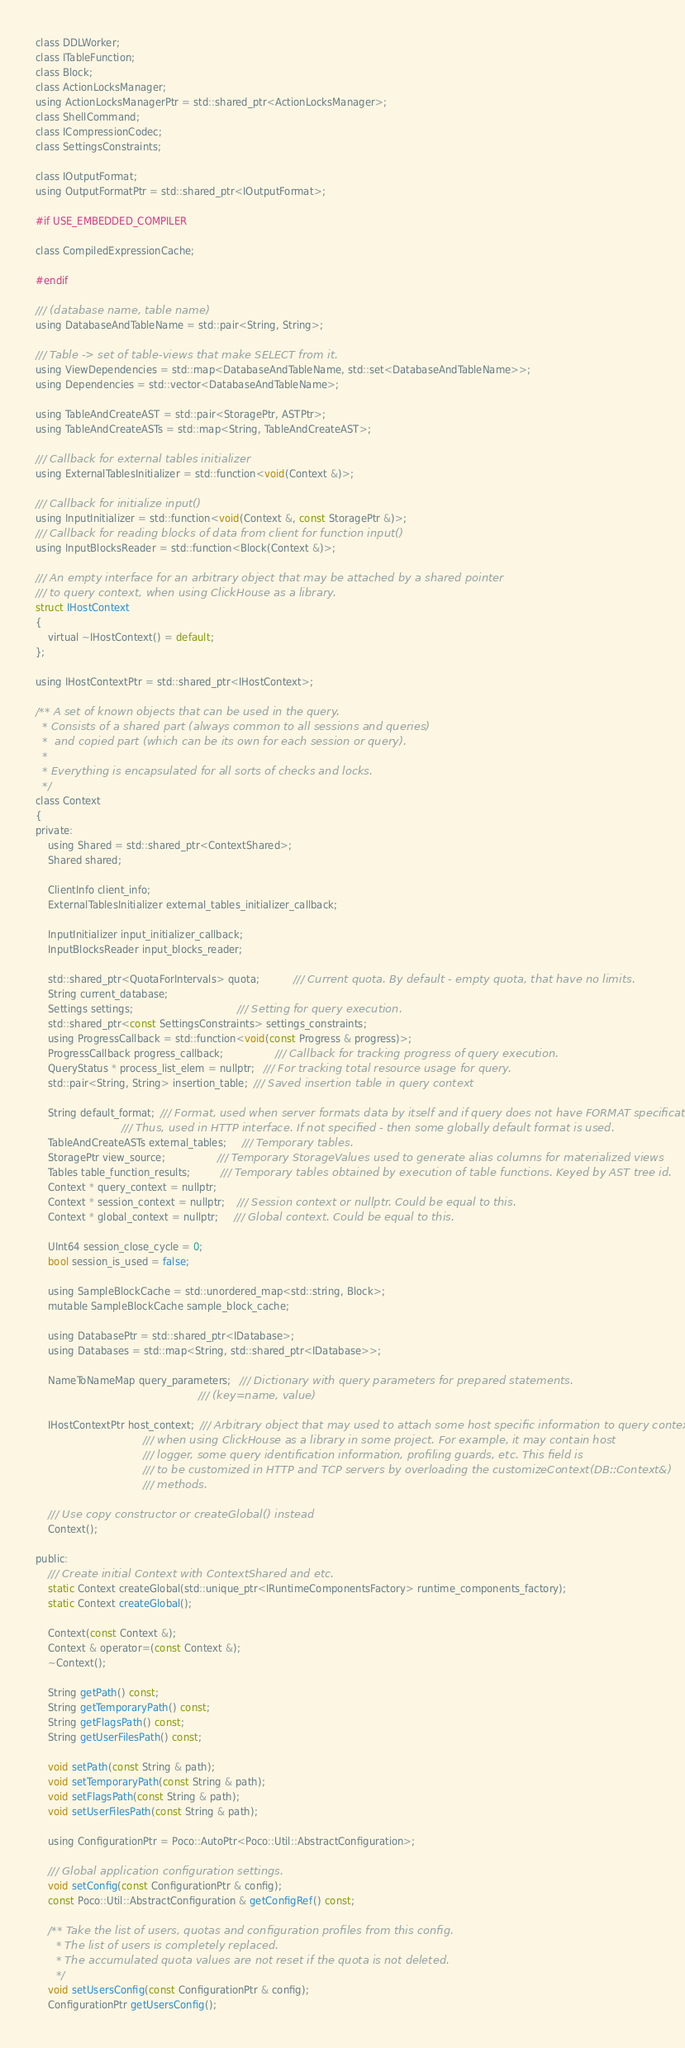Convert code to text. <code><loc_0><loc_0><loc_500><loc_500><_C_>class DDLWorker;
class ITableFunction;
class Block;
class ActionLocksManager;
using ActionLocksManagerPtr = std::shared_ptr<ActionLocksManager>;
class ShellCommand;
class ICompressionCodec;
class SettingsConstraints;

class IOutputFormat;
using OutputFormatPtr = std::shared_ptr<IOutputFormat>;

#if USE_EMBEDDED_COMPILER

class CompiledExpressionCache;

#endif

/// (database name, table name)
using DatabaseAndTableName = std::pair<String, String>;

/// Table -> set of table-views that make SELECT from it.
using ViewDependencies = std::map<DatabaseAndTableName, std::set<DatabaseAndTableName>>;
using Dependencies = std::vector<DatabaseAndTableName>;

using TableAndCreateAST = std::pair<StoragePtr, ASTPtr>;
using TableAndCreateASTs = std::map<String, TableAndCreateAST>;

/// Callback for external tables initializer
using ExternalTablesInitializer = std::function<void(Context &)>;

/// Callback for initialize input()
using InputInitializer = std::function<void(Context &, const StoragePtr &)>;
/// Callback for reading blocks of data from client for function input()
using InputBlocksReader = std::function<Block(Context &)>;

/// An empty interface for an arbitrary object that may be attached by a shared pointer
/// to query context, when using ClickHouse as a library.
struct IHostContext
{
    virtual ~IHostContext() = default;
};

using IHostContextPtr = std::shared_ptr<IHostContext>;

/** A set of known objects that can be used in the query.
  * Consists of a shared part (always common to all sessions and queries)
  *  and copied part (which can be its own for each session or query).
  *
  * Everything is encapsulated for all sorts of checks and locks.
  */
class Context
{
private:
    using Shared = std::shared_ptr<ContextShared>;
    Shared shared;

    ClientInfo client_info;
    ExternalTablesInitializer external_tables_initializer_callback;

    InputInitializer input_initializer_callback;
    InputBlocksReader input_blocks_reader;

    std::shared_ptr<QuotaForIntervals> quota;           /// Current quota. By default - empty quota, that have no limits.
    String current_database;
    Settings settings;                                  /// Setting for query execution.
    std::shared_ptr<const SettingsConstraints> settings_constraints;
    using ProgressCallback = std::function<void(const Progress & progress)>;
    ProgressCallback progress_callback;                 /// Callback for tracking progress of query execution.
    QueryStatus * process_list_elem = nullptr;   /// For tracking total resource usage for query.
    std::pair<String, String> insertion_table;  /// Saved insertion table in query context

    String default_format;  /// Format, used when server formats data by itself and if query does not have FORMAT specification.
                            /// Thus, used in HTTP interface. If not specified - then some globally default format is used.
    TableAndCreateASTs external_tables;     /// Temporary tables.
    StoragePtr view_source;                 /// Temporary StorageValues used to generate alias columns for materialized views
    Tables table_function_results;          /// Temporary tables obtained by execution of table functions. Keyed by AST tree id.
    Context * query_context = nullptr;
    Context * session_context = nullptr;    /// Session context or nullptr. Could be equal to this.
    Context * global_context = nullptr;     /// Global context. Could be equal to this.

    UInt64 session_close_cycle = 0;
    bool session_is_used = false;

    using SampleBlockCache = std::unordered_map<std::string, Block>;
    mutable SampleBlockCache sample_block_cache;

    using DatabasePtr = std::shared_ptr<IDatabase>;
    using Databases = std::map<String, std::shared_ptr<IDatabase>>;

    NameToNameMap query_parameters;   /// Dictionary with query parameters for prepared statements.
                                                     /// (key=name, value)

    IHostContextPtr host_context;  /// Arbitrary object that may used to attach some host specific information to query context,
                                   /// when using ClickHouse as a library in some project. For example, it may contain host
                                   /// logger, some query identification information, profiling guards, etc. This field is
                                   /// to be customized in HTTP and TCP servers by overloading the customizeContext(DB::Context&)
                                   /// methods.

    /// Use copy constructor or createGlobal() instead
    Context();

public:
    /// Create initial Context with ContextShared and etc.
    static Context createGlobal(std::unique_ptr<IRuntimeComponentsFactory> runtime_components_factory);
    static Context createGlobal();

    Context(const Context &);
    Context & operator=(const Context &);
    ~Context();

    String getPath() const;
    String getTemporaryPath() const;
    String getFlagsPath() const;
    String getUserFilesPath() const;

    void setPath(const String & path);
    void setTemporaryPath(const String & path);
    void setFlagsPath(const String & path);
    void setUserFilesPath(const String & path);

    using ConfigurationPtr = Poco::AutoPtr<Poco::Util::AbstractConfiguration>;

    /// Global application configuration settings.
    void setConfig(const ConfigurationPtr & config);
    const Poco::Util::AbstractConfiguration & getConfigRef() const;

    /** Take the list of users, quotas and configuration profiles from this config.
      * The list of users is completely replaced.
      * The accumulated quota values are not reset if the quota is not deleted.
      */
    void setUsersConfig(const ConfigurationPtr & config);
    ConfigurationPtr getUsersConfig();
</code> 